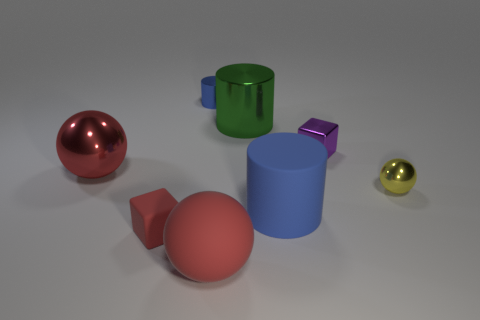What size is the other thing that is the same shape as the purple metal thing?
Give a very brief answer. Small. There is a small matte cube; does it have the same color as the ball that is on the left side of the tiny metallic cylinder?
Offer a terse response. Yes. Are there any big rubber objects of the same shape as the blue shiny thing?
Your answer should be compact. Yes. How many things are on the right side of the tiny red object and in front of the large blue matte cylinder?
Offer a terse response. 1. What shape is the blue object in front of the big green shiny cylinder?
Give a very brief answer. Cylinder. What number of blocks are the same material as the large blue thing?
Offer a terse response. 1. There is a blue matte thing; does it have the same shape as the blue object that is behind the tiny yellow ball?
Provide a short and direct response. Yes. Is there a big cylinder behind the blue object that is on the right side of the small blue metal object behind the large blue cylinder?
Make the answer very short. Yes. What size is the blue cylinder that is right of the big red rubber object?
Offer a terse response. Large. What material is the green object that is the same size as the blue rubber thing?
Give a very brief answer. Metal. 